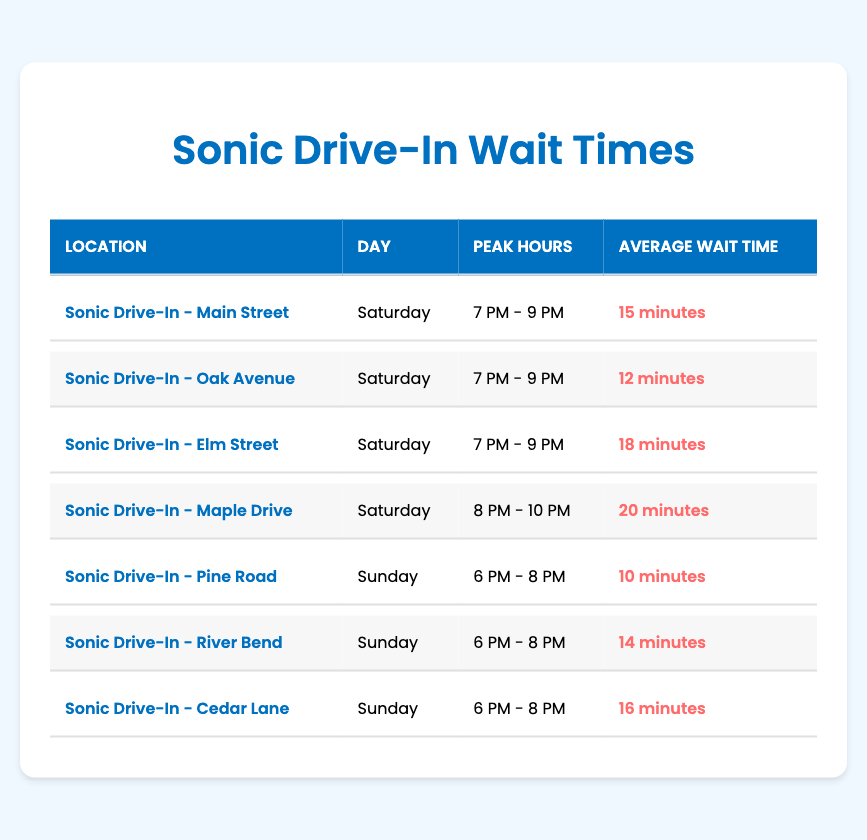What's the average wait time at Sonic Drive-In - Main Street on Saturday? According to the table, the average wait time at Sonic Drive-In - Main Street on Saturday is 15 minutes.
Answer: 15 minutes Which location has the longest average wait time on Saturday during peak hours? From the table, Sonic Drive-In - Elm Street has the longest average wait time on Saturday at 18 minutes, compared to Main Street (15 minutes) and Oak Avenue (12 minutes).
Answer: Sonic Drive-In - Elm Street What is the average wait time across all locations for Sundays? The locations on Sundays are Pine Road (10 minutes), River Bend (14 minutes), and Cedar Lane (16 minutes). The sum is 10 + 14 + 16 = 40 minutes for 3 locations. Dividing by 3, the average wait time is 40/3 ≈ 13.33 minutes.
Answer: Approximately 13.33 minutes Is the average wait time at Sonic Drive-In - River Bend higher than at Cedar Lane on Sunday? Sonic Drive-In - River Bend has an average wait time of 14 minutes, while Cedar Lane has 16 minutes. Since 14 is less than 16, River Bend's wait time is not higher than Cedar Lane's.
Answer: No What is the total average wait time for all listed drive-in locations during peak hours? Adding all average wait times from the table: 15 (Main Street) + 12 (Oak Avenue) + 18 (Elm Street) + 20 (Maple Drive) + 10 (Pine Road) + 14 (River Bend) + 16 (Cedar Lane) = 105 minutes. There are 7 locations, so the total average wait time is 105/7 ≈ 15 minutes.
Answer: Approximately 15 minutes Which day has the lowest average wait time across all locations? On Saturday, the average wait times are 15, 12, and 18 minutes. On Sunday, the times are 10, 14, and 16 minutes. The total for Saturday is 45 minutes for 3 locations (15 + 12 + 18) = 15 minutes average, while Sunday totals 40 minutes for 3 locations (10 + 14 + 16) = 13.33 minutes average. Sunday has the lower average wait time.
Answer: Sunday How long is the average wait time at Sonic Drive-In - Maple Drive compared to the average wait time at Sonic Drive-In - Oak Avenue? Sonic Drive-In - Maple Drive has an average wait time of 20 minutes, while Oak Avenue has 12 minutes. Therefore, Maple Drive's wait time is greater. The difference is 20 - 12 = 8 minutes.
Answer: 20 minutes is greater than 12 minutes by 8 minutes Is the average wait time for Sonic Drive-In - Pine Road the shortest among the analyzed locations over the weekend? On Saturday, Pine Road's wait time is not applicable, but for Sunday, it is 10 minutes, which is the lowest among Sunday times of 10 (Pine Road), 14 (River Bend), and 16 (Cedar Lane). Saturday also has a lower minimum than Pine Road.
Answer: Yes 